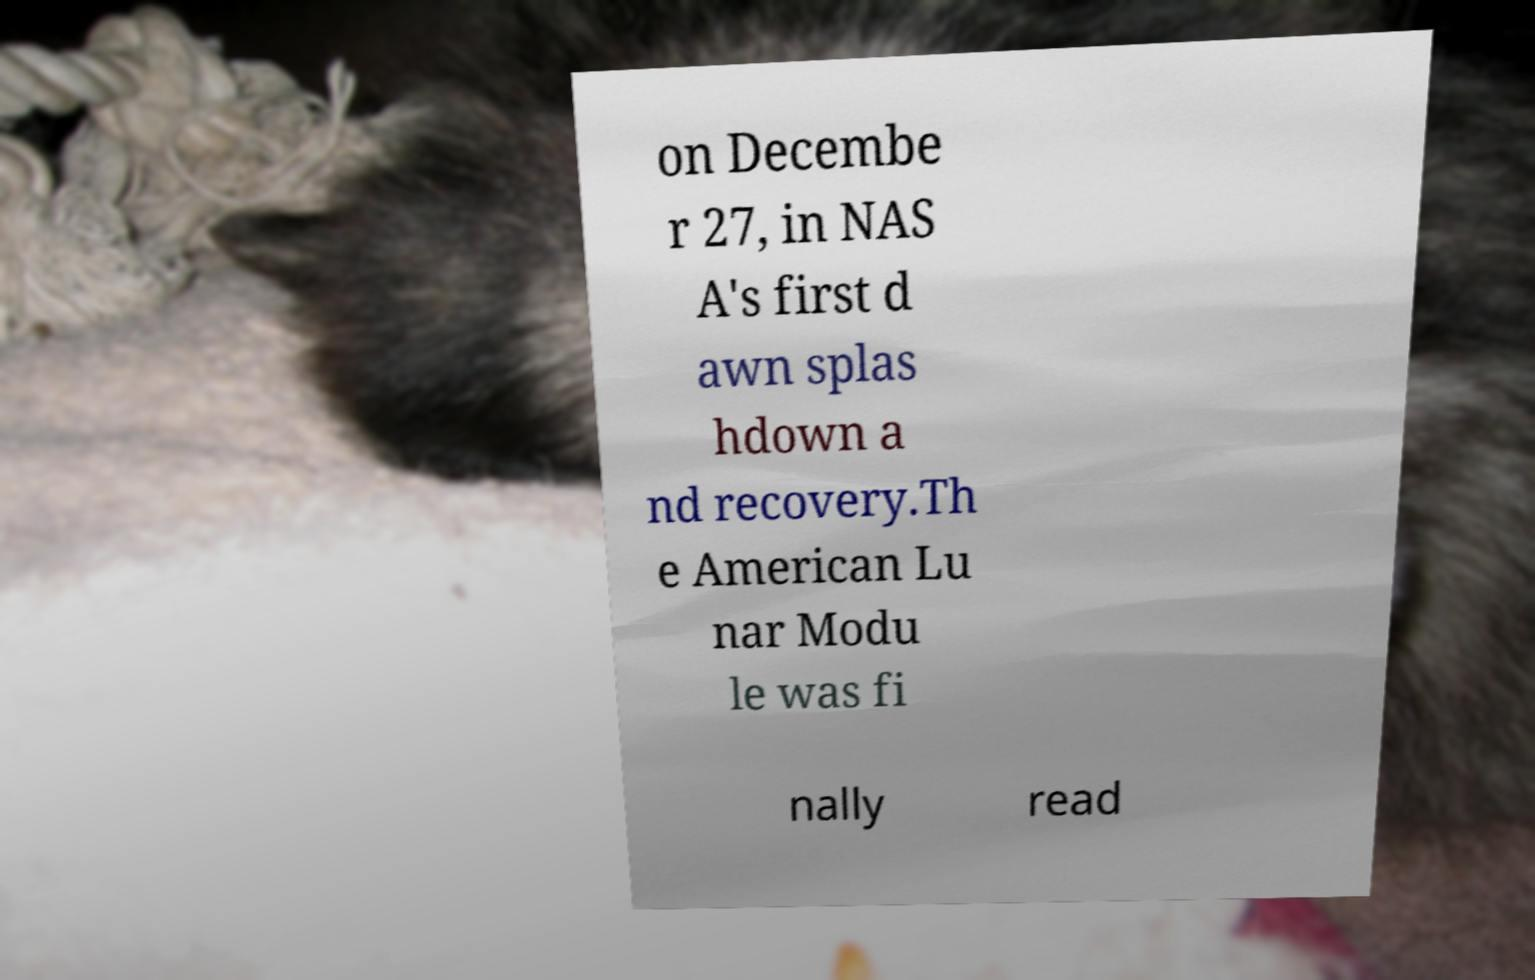There's text embedded in this image that I need extracted. Can you transcribe it verbatim? on Decembe r 27, in NAS A's first d awn splas hdown a nd recovery.Th e American Lu nar Modu le was fi nally read 